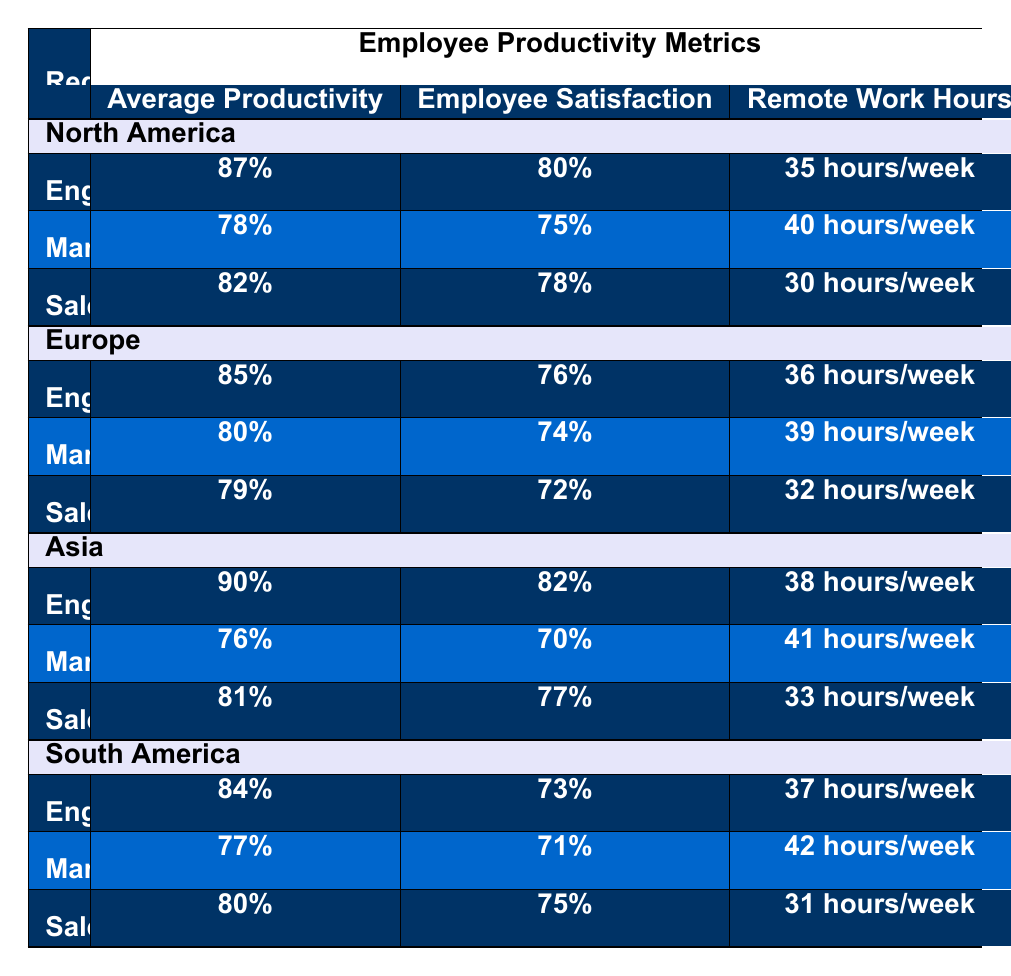What is the average productivity in the Engineering department for North America? The table shows that the average productivity for the Engineering department in North America is 87%.
Answer: 87% Which region has the highest employee satisfaction in the Sales department? Comparing employee satisfaction values in the Sales department across all regions, Asia has the highest satisfaction at 77%.
Answer: Asia What is the remote work hours for the Marketing department in South America? The table indicates that the remote work hours for the Marketing department in South America is 42 hours/week.
Answer: 42 hours/week Is the employee satisfaction in Europe’s Engineering department higher than in South America’s Engineering department? In Europe, the Engineering department has 76% satisfaction, while South America has 73%. Since 76% is greater than 73%, the statement is true.
Answer: Yes Which region has the lowest average productivity across all departments? To find the lowest average productivity, compare the averages: North America (82%), Europe (80%), Asia (82%). South America has an average of 80% (calculated as (84% + 77% + 80%)/3 = 80.33%). Therefore, South America has the lowest overall productivity.
Answer: South America If we want to find the average remote work hours in the Engineering department across all regions, what would it be? The remote work hours for Engineering are: 35 (NA) + 36 (EU) + 38 (AS) + 37 (SA) = 146 hours for 4 regions. The average is calculated as 146/4 = 36.5 hours/week.
Answer: 36.5 hours/week Does the Marketing department in North America have higher productivity than the Marketing department in Europe? North America's Marketing department has 78% productivity, while Europe's Marketing department has 80%. Since 78% is less than 80%, the statement is false.
Answer: No What is the difference in employee satisfaction between Engineering and Sales departments in Asia? The employee satisfaction for Engineering in Asia is 82% and for Sales is 81%. The difference is calculated as 82% - 81% = 1%.
Answer: 1% Which region has the highest average remote work hours overall? To find the highest remote work hours, the values are: NA (35), EU (36), AS (38), SA (37). The highest is in Asia with 38 hours/week.
Answer: Asia Are the average productivity rates in the Marketing department across North America and Europe equal? North America has an average productivity of 78%, and Europe has an average productivity of 80%. Since 78% is not equal to 80%, the statement is false.
Answer: No 